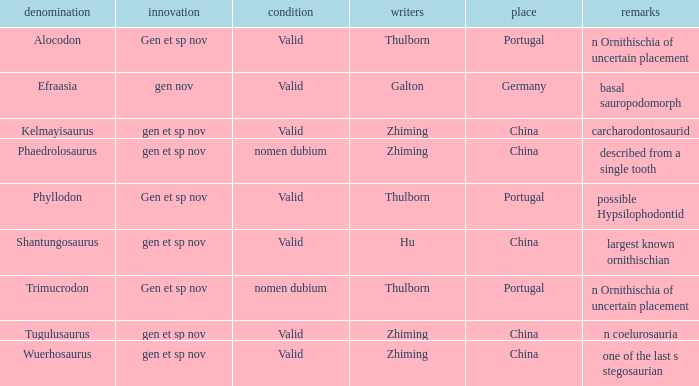What is the Novelty of the dinosaur that was named by the Author, Zhiming, and whose Notes are, "carcharodontosaurid"? Gen et sp nov. 